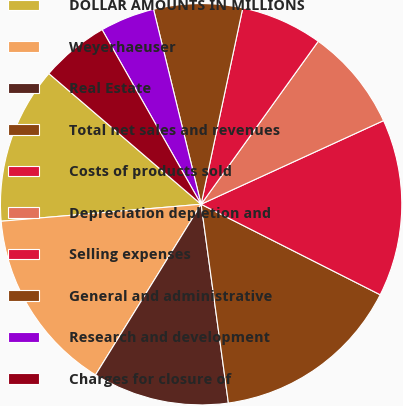<chart> <loc_0><loc_0><loc_500><loc_500><pie_chart><fcel>DOLLAR AMOUNTS IN MILLIONS<fcel>Weyerhaeuser<fcel>Real Estate<fcel>Total net sales and revenues<fcel>Costs of products sold<fcel>Depreciation depletion and<fcel>Selling expenses<fcel>General and administrative<fcel>Research and development<fcel>Charges for closure of<nl><fcel>12.64%<fcel>14.83%<fcel>10.99%<fcel>15.38%<fcel>14.29%<fcel>8.24%<fcel>6.59%<fcel>7.14%<fcel>4.4%<fcel>5.5%<nl></chart> 